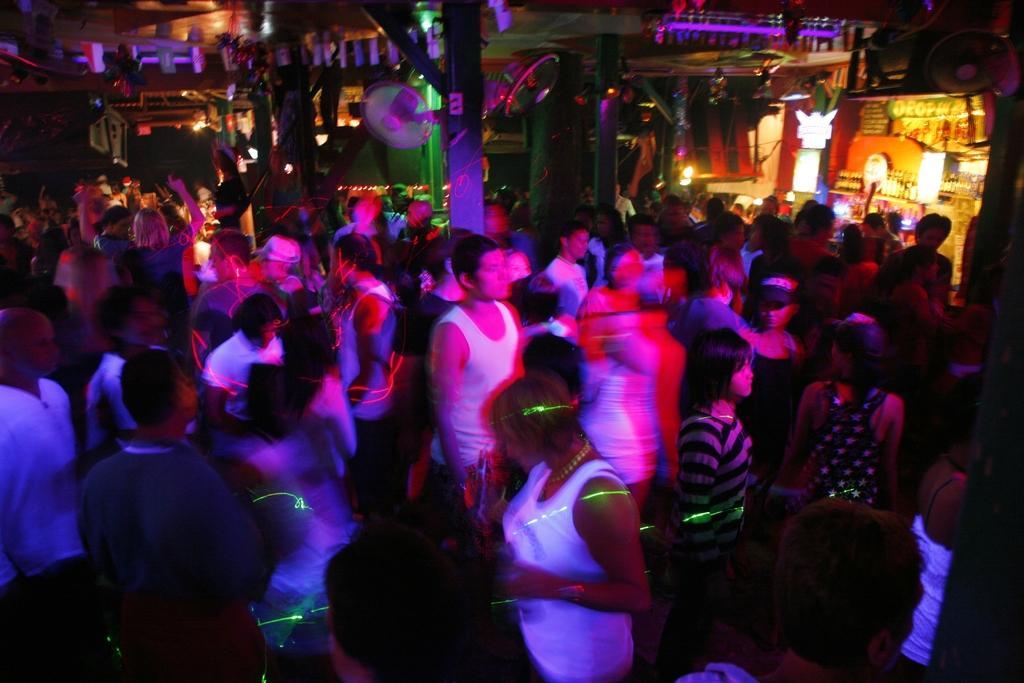Describe this image in one or two sentences. In this image there are a group of people standing, there are person truncated towards the left of the image, there are persons truncated towards the bottom of the image, there are objects truncated towards the right of the image, there are pillars, there are objects in the pillars, there are lights, there is the wall, there is a board on the wall, there is text on the board, there are objects, there is a pole truncated towards the top of the image. 